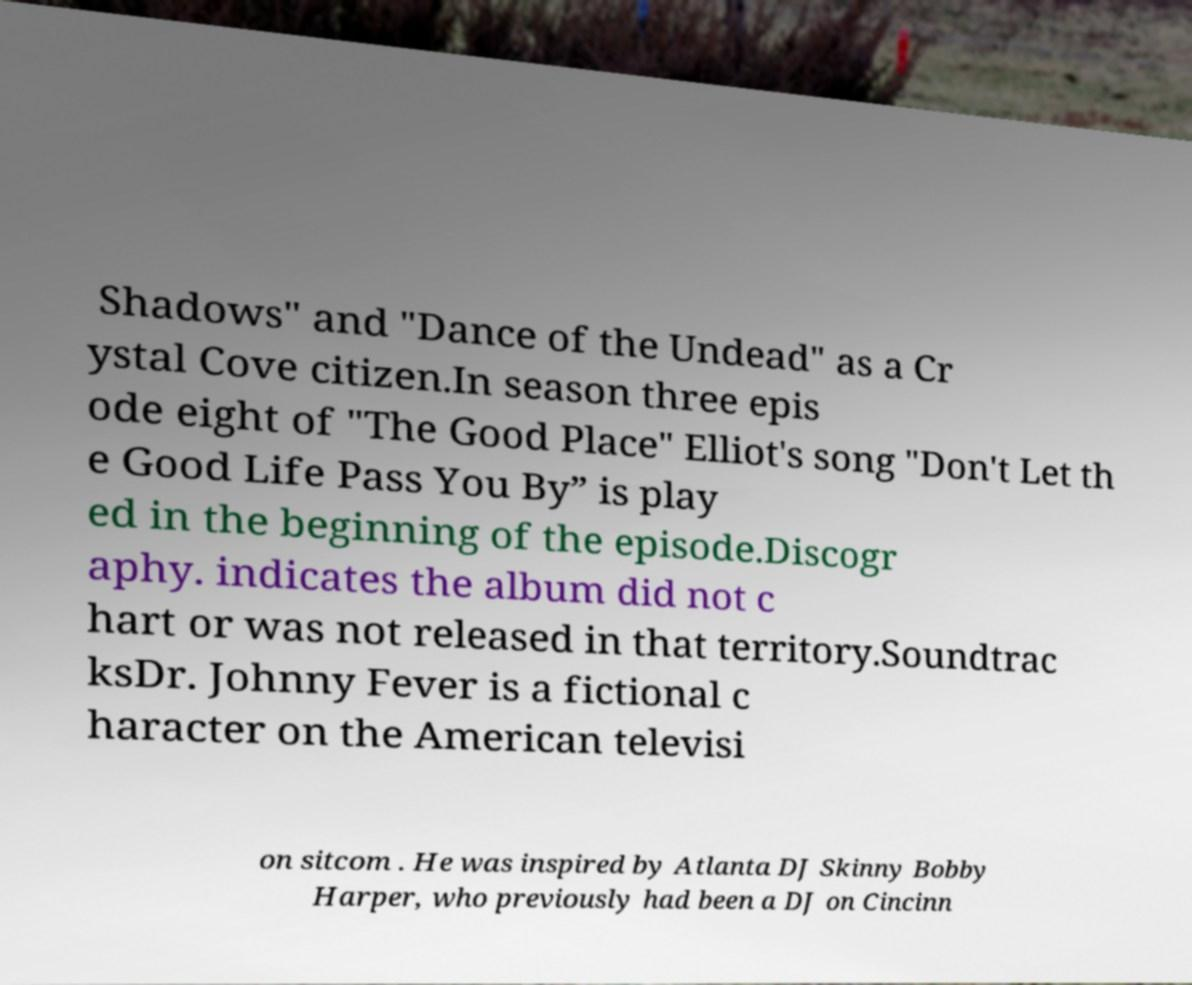Could you extract and type out the text from this image? Shadows" and "Dance of the Undead" as a Cr ystal Cove citizen.In season three epis ode eight of "The Good Place" Elliot's song "Don't Let th e Good Life Pass You By” is play ed in the beginning of the episode.Discogr aphy. indicates the album did not c hart or was not released in that territory.Soundtrac ksDr. Johnny Fever is a fictional c haracter on the American televisi on sitcom . He was inspired by Atlanta DJ Skinny Bobby Harper, who previously had been a DJ on Cincinn 